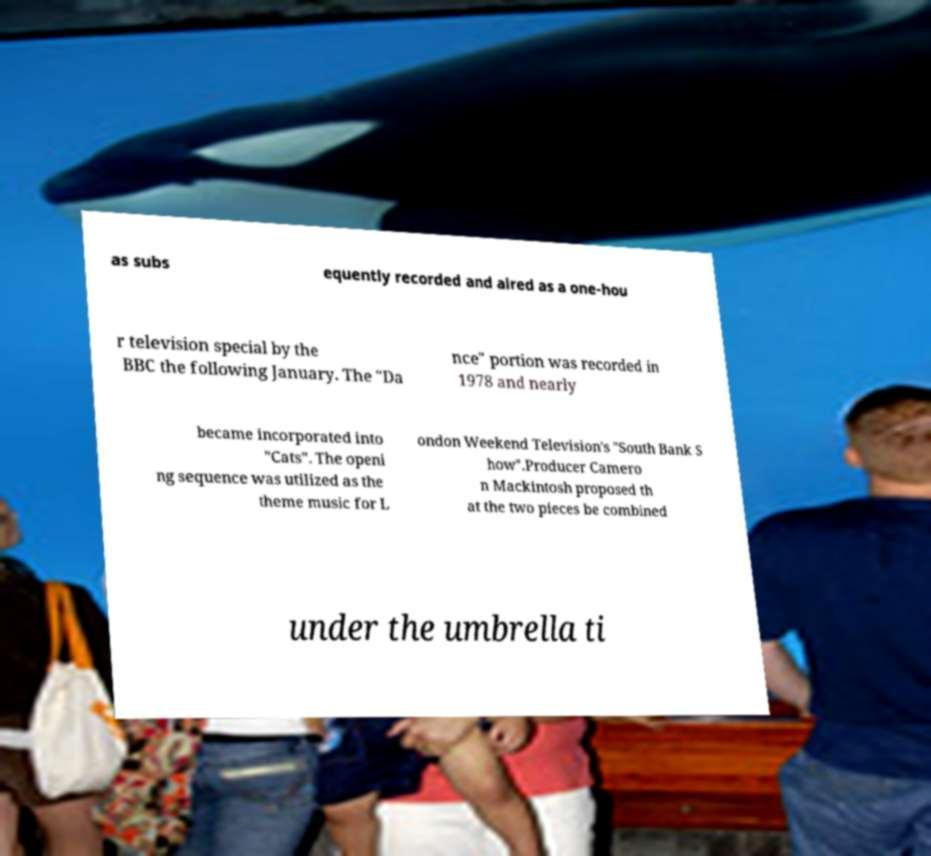I need the written content from this picture converted into text. Can you do that? as subs equently recorded and aired as a one-hou r television special by the BBC the following January. The "Da nce" portion was recorded in 1978 and nearly became incorporated into "Cats". The openi ng sequence was utilized as the theme music for L ondon Weekend Television's "South Bank S how".Producer Camero n Mackintosh proposed th at the two pieces be combined under the umbrella ti 